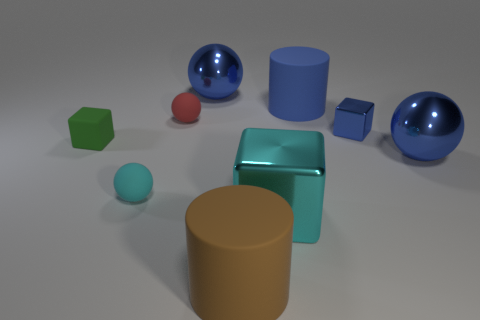Subtract 1 spheres. How many spheres are left? 3 Subtract all purple balls. Subtract all blue blocks. How many balls are left? 4 Subtract all blocks. How many objects are left? 6 Add 1 big balls. How many big balls are left? 3 Add 9 cyan rubber things. How many cyan rubber things exist? 10 Subtract 1 cyan spheres. How many objects are left? 8 Subtract all small cyan things. Subtract all big red rubber cylinders. How many objects are left? 8 